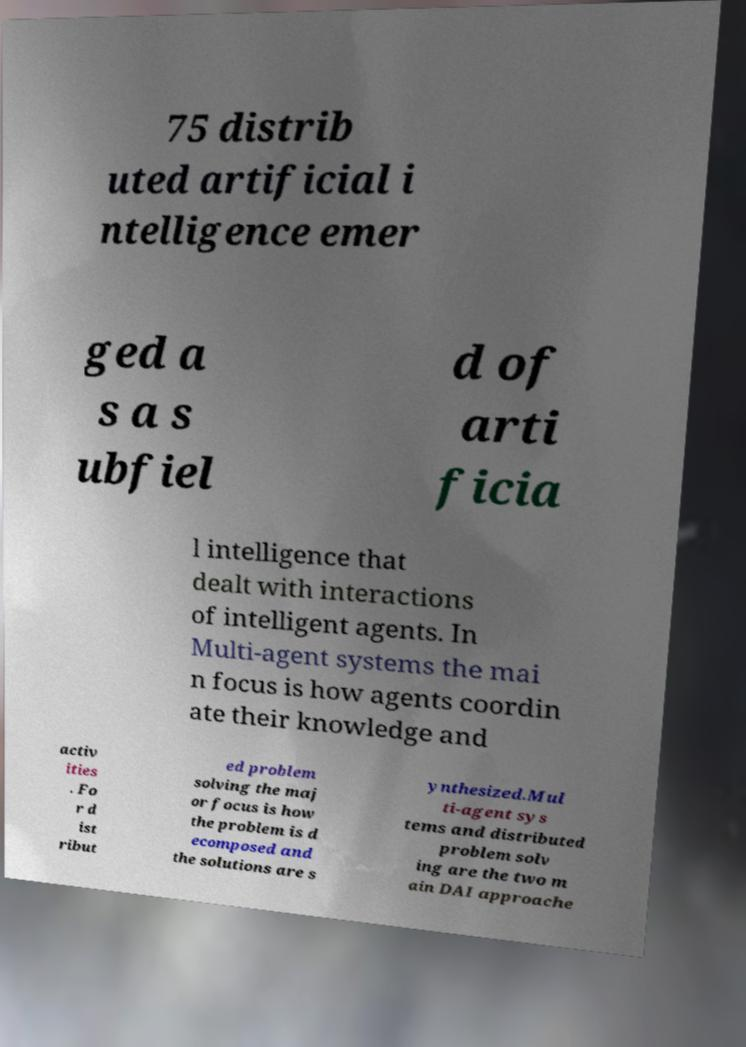Could you extract and type out the text from this image? 75 distrib uted artificial i ntelligence emer ged a s a s ubfiel d of arti ficia l intelligence that dealt with interactions of intelligent agents. In Multi-agent systems the mai n focus is how agents coordin ate their knowledge and activ ities . Fo r d ist ribut ed problem solving the maj or focus is how the problem is d ecomposed and the solutions are s ynthesized.Mul ti-agent sys tems and distributed problem solv ing are the two m ain DAI approache 